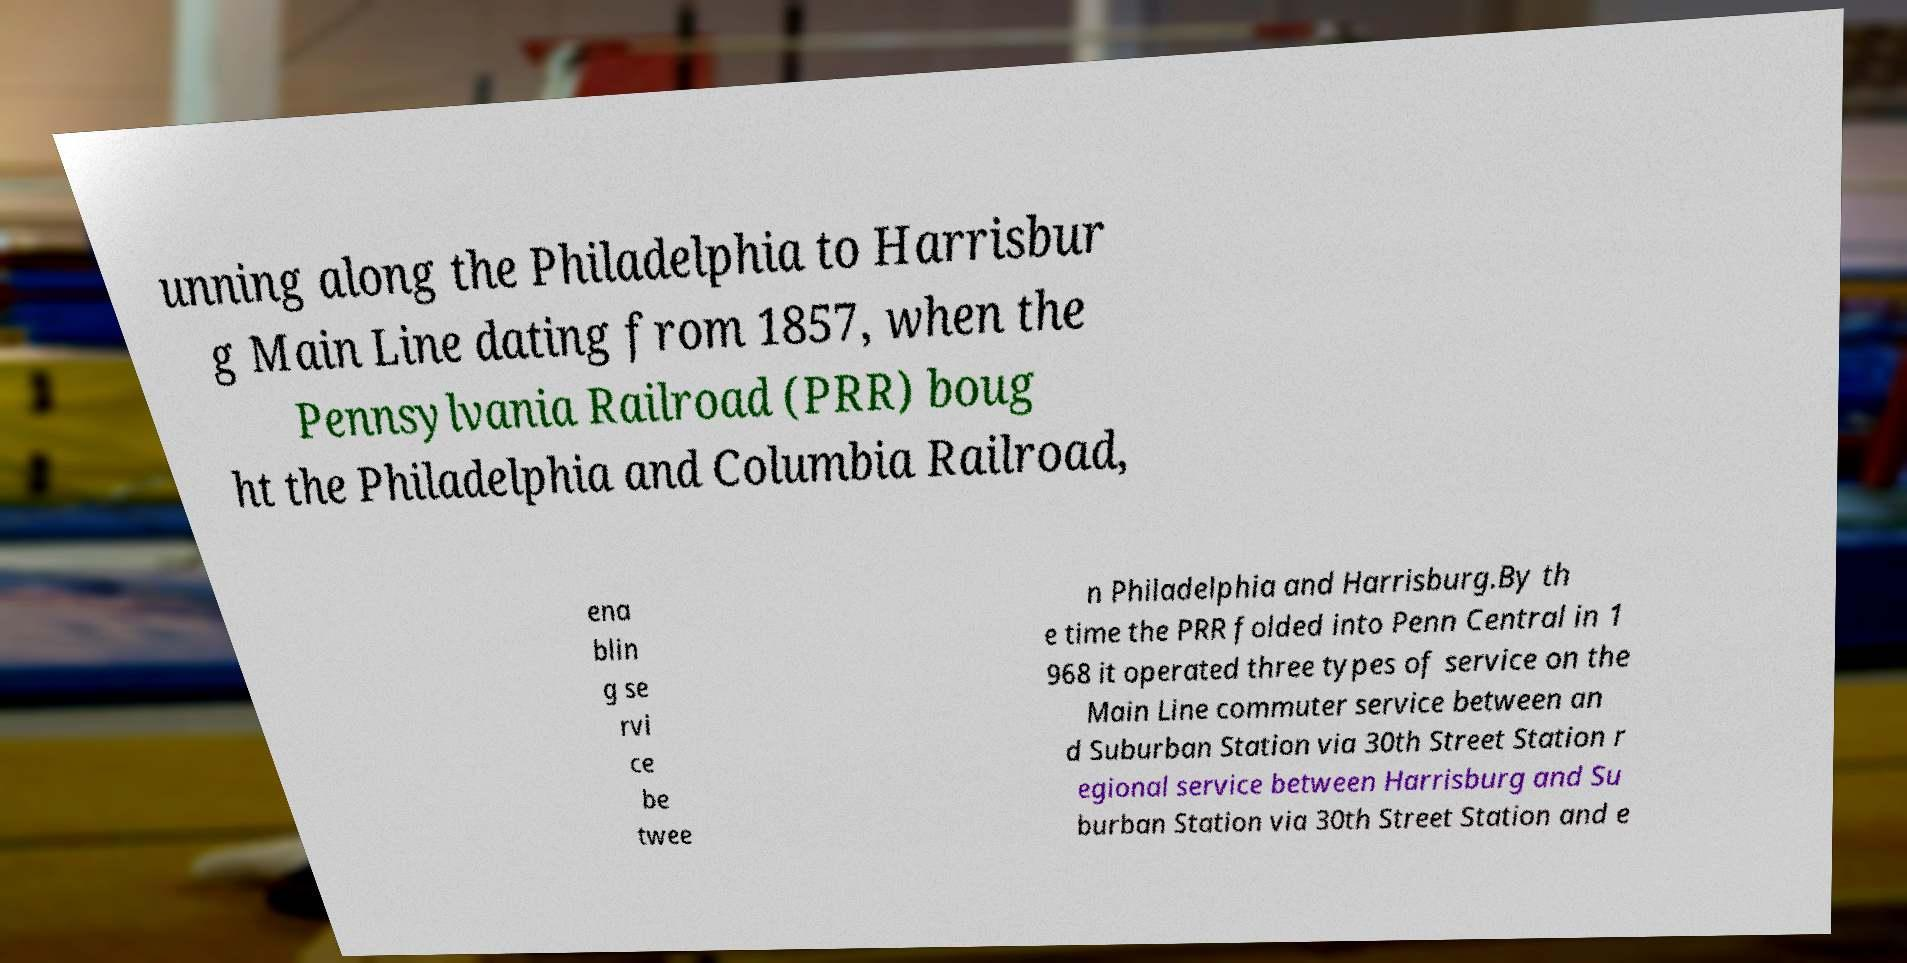Could you extract and type out the text from this image? unning along the Philadelphia to Harrisbur g Main Line dating from 1857, when the Pennsylvania Railroad (PRR) boug ht the Philadelphia and Columbia Railroad, ena blin g se rvi ce be twee n Philadelphia and Harrisburg.By th e time the PRR folded into Penn Central in 1 968 it operated three types of service on the Main Line commuter service between an d Suburban Station via 30th Street Station r egional service between Harrisburg and Su burban Station via 30th Street Station and e 